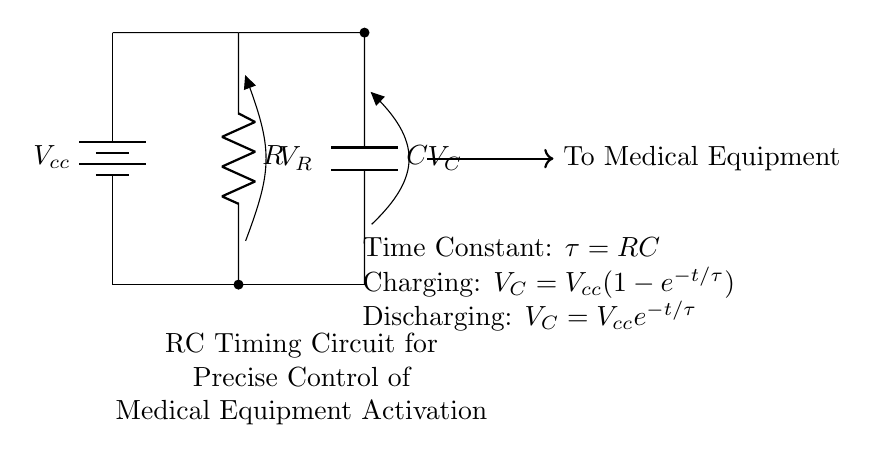What is the type of circuit shown? The circuit is an RC timing circuit, indicated by the presence of both a resistor and a capacitor in series, designed for timing applications.
Answer: RC timing circuit What is represented by \( V_{cc} \)? \( V_{cc} \) signifies the supply voltage for the circuit, which is connected at the top and provides power to the components.
Answer: Supply voltage What does \( R \) represent in the circuit? \( R \) represents the resistance in ohms, which affects the timing characteristics of the circuit; it is shown as a distinct component in the diagram.
Answer: Resistance What is the expression for the time constant \( \tau \)? The time constant \( \tau \) is defined as the product of resistance \( R \) and capacitance \( C \), indicating how quickly the circuit responds to changes in voltage.
Answer: \( RC \) How does the voltage across the capacitor change during charging? During charging, the voltage across the capacitor \( V_C \) increases according to the equation \( V_C = V_{cc}(1-e^{-t/\tau}) \), which describes the exponential growth toward \( V_{cc} \).
Answer: Exponential growth What happens to \( V_C \) during discharging? During discharging, \( V_C \) decreases according to the equation \( V_C = V_{cc}e^{-t/\tau} \), indicating a rapid initial drop that slows over time.
Answer: Exponential decay 